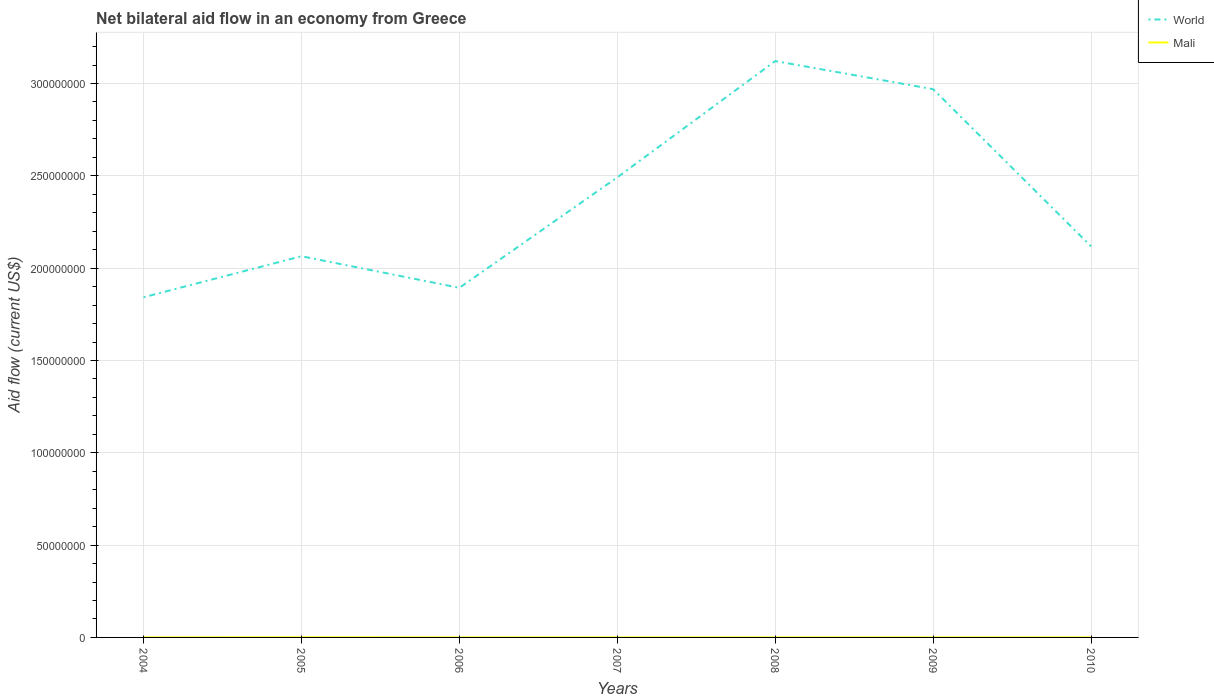Does the line corresponding to Mali intersect with the line corresponding to World?
Keep it short and to the point. No. In which year was the net bilateral aid flow in Mali maximum?
Your answer should be very brief. 2004. What is the total net bilateral aid flow in World in the graph?
Make the answer very short. -1.23e+08. What is the difference between the highest and the second highest net bilateral aid flow in World?
Your answer should be compact. 1.28e+08. What is the difference between the highest and the lowest net bilateral aid flow in World?
Provide a short and direct response. 3. How many lines are there?
Give a very brief answer. 2. How many years are there in the graph?
Provide a succinct answer. 7. Are the values on the major ticks of Y-axis written in scientific E-notation?
Provide a succinct answer. No. Does the graph contain any zero values?
Offer a very short reply. No. Where does the legend appear in the graph?
Your response must be concise. Top right. What is the title of the graph?
Provide a succinct answer. Net bilateral aid flow in an economy from Greece. What is the label or title of the X-axis?
Give a very brief answer. Years. What is the label or title of the Y-axis?
Keep it short and to the point. Aid flow (current US$). What is the Aid flow (current US$) in World in 2004?
Keep it short and to the point. 1.84e+08. What is the Aid flow (current US$) of World in 2005?
Keep it short and to the point. 2.06e+08. What is the Aid flow (current US$) of Mali in 2005?
Offer a terse response. 7.00e+04. What is the Aid flow (current US$) in World in 2006?
Provide a short and direct response. 1.89e+08. What is the Aid flow (current US$) of World in 2007?
Provide a short and direct response. 2.49e+08. What is the Aid flow (current US$) in World in 2008?
Keep it short and to the point. 3.12e+08. What is the Aid flow (current US$) in Mali in 2008?
Make the answer very short. 10000. What is the Aid flow (current US$) of World in 2009?
Provide a short and direct response. 2.97e+08. What is the Aid flow (current US$) of World in 2010?
Offer a very short reply. 2.12e+08. What is the Aid flow (current US$) in Mali in 2010?
Make the answer very short. 10000. Across all years, what is the maximum Aid flow (current US$) of World?
Your answer should be very brief. 3.12e+08. Across all years, what is the minimum Aid flow (current US$) in World?
Give a very brief answer. 1.84e+08. What is the total Aid flow (current US$) in World in the graph?
Offer a very short reply. 1.65e+09. What is the difference between the Aid flow (current US$) of World in 2004 and that in 2005?
Ensure brevity in your answer.  -2.22e+07. What is the difference between the Aid flow (current US$) in Mali in 2004 and that in 2005?
Your answer should be compact. -6.00e+04. What is the difference between the Aid flow (current US$) in World in 2004 and that in 2006?
Offer a terse response. -5.11e+06. What is the difference between the Aid flow (current US$) in World in 2004 and that in 2007?
Keep it short and to the point. -6.50e+07. What is the difference between the Aid flow (current US$) of Mali in 2004 and that in 2007?
Provide a short and direct response. 0. What is the difference between the Aid flow (current US$) in World in 2004 and that in 2008?
Your answer should be very brief. -1.28e+08. What is the difference between the Aid flow (current US$) of World in 2004 and that in 2009?
Provide a succinct answer. -1.13e+08. What is the difference between the Aid flow (current US$) of World in 2004 and that in 2010?
Your answer should be compact. -2.76e+07. What is the difference between the Aid flow (current US$) in World in 2005 and that in 2006?
Your response must be concise. 1.71e+07. What is the difference between the Aid flow (current US$) in World in 2005 and that in 2007?
Offer a very short reply. -4.27e+07. What is the difference between the Aid flow (current US$) in Mali in 2005 and that in 2007?
Your answer should be very brief. 6.00e+04. What is the difference between the Aid flow (current US$) of World in 2005 and that in 2008?
Your answer should be very brief. -1.06e+08. What is the difference between the Aid flow (current US$) of World in 2005 and that in 2009?
Offer a very short reply. -9.05e+07. What is the difference between the Aid flow (current US$) in World in 2005 and that in 2010?
Make the answer very short. -5.35e+06. What is the difference between the Aid flow (current US$) in World in 2006 and that in 2007?
Make the answer very short. -5.98e+07. What is the difference between the Aid flow (current US$) in World in 2006 and that in 2008?
Your response must be concise. -1.23e+08. What is the difference between the Aid flow (current US$) of Mali in 2006 and that in 2008?
Ensure brevity in your answer.  0. What is the difference between the Aid flow (current US$) of World in 2006 and that in 2009?
Ensure brevity in your answer.  -1.08e+08. What is the difference between the Aid flow (current US$) of World in 2006 and that in 2010?
Give a very brief answer. -2.25e+07. What is the difference between the Aid flow (current US$) of World in 2007 and that in 2008?
Your answer should be very brief. -6.30e+07. What is the difference between the Aid flow (current US$) of Mali in 2007 and that in 2008?
Your answer should be compact. 0. What is the difference between the Aid flow (current US$) in World in 2007 and that in 2009?
Provide a short and direct response. -4.78e+07. What is the difference between the Aid flow (current US$) in Mali in 2007 and that in 2009?
Ensure brevity in your answer.  0. What is the difference between the Aid flow (current US$) of World in 2007 and that in 2010?
Your answer should be compact. 3.74e+07. What is the difference between the Aid flow (current US$) in World in 2008 and that in 2009?
Offer a terse response. 1.52e+07. What is the difference between the Aid flow (current US$) in Mali in 2008 and that in 2009?
Give a very brief answer. 0. What is the difference between the Aid flow (current US$) of World in 2008 and that in 2010?
Keep it short and to the point. 1.00e+08. What is the difference between the Aid flow (current US$) in Mali in 2008 and that in 2010?
Your answer should be compact. 0. What is the difference between the Aid flow (current US$) in World in 2009 and that in 2010?
Your answer should be very brief. 8.51e+07. What is the difference between the Aid flow (current US$) in Mali in 2009 and that in 2010?
Offer a terse response. 0. What is the difference between the Aid flow (current US$) in World in 2004 and the Aid flow (current US$) in Mali in 2005?
Offer a terse response. 1.84e+08. What is the difference between the Aid flow (current US$) of World in 2004 and the Aid flow (current US$) of Mali in 2006?
Offer a terse response. 1.84e+08. What is the difference between the Aid flow (current US$) of World in 2004 and the Aid flow (current US$) of Mali in 2007?
Provide a succinct answer. 1.84e+08. What is the difference between the Aid flow (current US$) in World in 2004 and the Aid flow (current US$) in Mali in 2008?
Provide a short and direct response. 1.84e+08. What is the difference between the Aid flow (current US$) in World in 2004 and the Aid flow (current US$) in Mali in 2009?
Keep it short and to the point. 1.84e+08. What is the difference between the Aid flow (current US$) of World in 2004 and the Aid flow (current US$) of Mali in 2010?
Provide a succinct answer. 1.84e+08. What is the difference between the Aid flow (current US$) in World in 2005 and the Aid flow (current US$) in Mali in 2006?
Provide a short and direct response. 2.06e+08. What is the difference between the Aid flow (current US$) in World in 2005 and the Aid flow (current US$) in Mali in 2007?
Give a very brief answer. 2.06e+08. What is the difference between the Aid flow (current US$) in World in 2005 and the Aid flow (current US$) in Mali in 2008?
Your answer should be very brief. 2.06e+08. What is the difference between the Aid flow (current US$) in World in 2005 and the Aid flow (current US$) in Mali in 2009?
Your response must be concise. 2.06e+08. What is the difference between the Aid flow (current US$) of World in 2005 and the Aid flow (current US$) of Mali in 2010?
Provide a short and direct response. 2.06e+08. What is the difference between the Aid flow (current US$) of World in 2006 and the Aid flow (current US$) of Mali in 2007?
Your answer should be very brief. 1.89e+08. What is the difference between the Aid flow (current US$) in World in 2006 and the Aid flow (current US$) in Mali in 2008?
Your response must be concise. 1.89e+08. What is the difference between the Aid flow (current US$) in World in 2006 and the Aid flow (current US$) in Mali in 2009?
Ensure brevity in your answer.  1.89e+08. What is the difference between the Aid flow (current US$) of World in 2006 and the Aid flow (current US$) of Mali in 2010?
Keep it short and to the point. 1.89e+08. What is the difference between the Aid flow (current US$) of World in 2007 and the Aid flow (current US$) of Mali in 2008?
Provide a short and direct response. 2.49e+08. What is the difference between the Aid flow (current US$) of World in 2007 and the Aid flow (current US$) of Mali in 2009?
Offer a very short reply. 2.49e+08. What is the difference between the Aid flow (current US$) in World in 2007 and the Aid flow (current US$) in Mali in 2010?
Your answer should be compact. 2.49e+08. What is the difference between the Aid flow (current US$) in World in 2008 and the Aid flow (current US$) in Mali in 2009?
Provide a succinct answer. 3.12e+08. What is the difference between the Aid flow (current US$) in World in 2008 and the Aid flow (current US$) in Mali in 2010?
Make the answer very short. 3.12e+08. What is the difference between the Aid flow (current US$) in World in 2009 and the Aid flow (current US$) in Mali in 2010?
Offer a terse response. 2.97e+08. What is the average Aid flow (current US$) in World per year?
Offer a very short reply. 2.36e+08. What is the average Aid flow (current US$) in Mali per year?
Your response must be concise. 1.86e+04. In the year 2004, what is the difference between the Aid flow (current US$) in World and Aid flow (current US$) in Mali?
Your answer should be compact. 1.84e+08. In the year 2005, what is the difference between the Aid flow (current US$) in World and Aid flow (current US$) in Mali?
Your response must be concise. 2.06e+08. In the year 2006, what is the difference between the Aid flow (current US$) in World and Aid flow (current US$) in Mali?
Your response must be concise. 1.89e+08. In the year 2007, what is the difference between the Aid flow (current US$) in World and Aid flow (current US$) in Mali?
Provide a succinct answer. 2.49e+08. In the year 2008, what is the difference between the Aid flow (current US$) in World and Aid flow (current US$) in Mali?
Ensure brevity in your answer.  3.12e+08. In the year 2009, what is the difference between the Aid flow (current US$) in World and Aid flow (current US$) in Mali?
Ensure brevity in your answer.  2.97e+08. In the year 2010, what is the difference between the Aid flow (current US$) of World and Aid flow (current US$) of Mali?
Make the answer very short. 2.12e+08. What is the ratio of the Aid flow (current US$) of World in 2004 to that in 2005?
Provide a succinct answer. 0.89. What is the ratio of the Aid flow (current US$) of Mali in 2004 to that in 2005?
Provide a succinct answer. 0.14. What is the ratio of the Aid flow (current US$) in World in 2004 to that in 2006?
Your response must be concise. 0.97. What is the ratio of the Aid flow (current US$) in World in 2004 to that in 2007?
Ensure brevity in your answer.  0.74. What is the ratio of the Aid flow (current US$) of World in 2004 to that in 2008?
Your answer should be compact. 0.59. What is the ratio of the Aid flow (current US$) in World in 2004 to that in 2009?
Give a very brief answer. 0.62. What is the ratio of the Aid flow (current US$) of World in 2004 to that in 2010?
Offer a terse response. 0.87. What is the ratio of the Aid flow (current US$) in Mali in 2004 to that in 2010?
Offer a terse response. 1. What is the ratio of the Aid flow (current US$) of World in 2005 to that in 2006?
Make the answer very short. 1.09. What is the ratio of the Aid flow (current US$) of Mali in 2005 to that in 2006?
Your answer should be compact. 7. What is the ratio of the Aid flow (current US$) in World in 2005 to that in 2007?
Provide a succinct answer. 0.83. What is the ratio of the Aid flow (current US$) of Mali in 2005 to that in 2007?
Offer a terse response. 7. What is the ratio of the Aid flow (current US$) in World in 2005 to that in 2008?
Provide a succinct answer. 0.66. What is the ratio of the Aid flow (current US$) in Mali in 2005 to that in 2008?
Provide a short and direct response. 7. What is the ratio of the Aid flow (current US$) of World in 2005 to that in 2009?
Provide a succinct answer. 0.7. What is the ratio of the Aid flow (current US$) of Mali in 2005 to that in 2009?
Your response must be concise. 7. What is the ratio of the Aid flow (current US$) in World in 2005 to that in 2010?
Provide a short and direct response. 0.97. What is the ratio of the Aid flow (current US$) in World in 2006 to that in 2007?
Provide a succinct answer. 0.76. What is the ratio of the Aid flow (current US$) of Mali in 2006 to that in 2007?
Provide a short and direct response. 1. What is the ratio of the Aid flow (current US$) in World in 2006 to that in 2008?
Make the answer very short. 0.61. What is the ratio of the Aid flow (current US$) in Mali in 2006 to that in 2008?
Ensure brevity in your answer.  1. What is the ratio of the Aid flow (current US$) of World in 2006 to that in 2009?
Offer a terse response. 0.64. What is the ratio of the Aid flow (current US$) in Mali in 2006 to that in 2009?
Offer a terse response. 1. What is the ratio of the Aid flow (current US$) of World in 2006 to that in 2010?
Provide a short and direct response. 0.89. What is the ratio of the Aid flow (current US$) of World in 2007 to that in 2008?
Give a very brief answer. 0.8. What is the ratio of the Aid flow (current US$) in World in 2007 to that in 2009?
Your answer should be compact. 0.84. What is the ratio of the Aid flow (current US$) in World in 2007 to that in 2010?
Your response must be concise. 1.18. What is the ratio of the Aid flow (current US$) of World in 2008 to that in 2009?
Your response must be concise. 1.05. What is the ratio of the Aid flow (current US$) of World in 2008 to that in 2010?
Give a very brief answer. 1.47. What is the ratio of the Aid flow (current US$) of Mali in 2008 to that in 2010?
Your answer should be very brief. 1. What is the ratio of the Aid flow (current US$) in World in 2009 to that in 2010?
Ensure brevity in your answer.  1.4. What is the ratio of the Aid flow (current US$) in Mali in 2009 to that in 2010?
Give a very brief answer. 1. What is the difference between the highest and the second highest Aid flow (current US$) in World?
Your answer should be compact. 1.52e+07. What is the difference between the highest and the second highest Aid flow (current US$) in Mali?
Keep it short and to the point. 6.00e+04. What is the difference between the highest and the lowest Aid flow (current US$) in World?
Ensure brevity in your answer.  1.28e+08. 